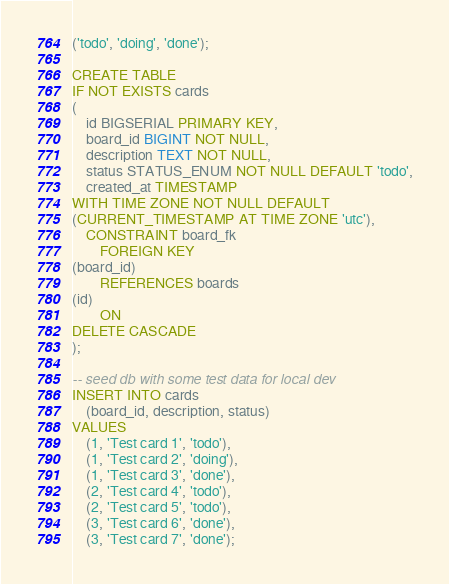Convert code to text. <code><loc_0><loc_0><loc_500><loc_500><_SQL_>('todo', 'doing', 'done');

CREATE TABLE
IF NOT EXISTS cards
(
    id BIGSERIAL PRIMARY KEY,
    board_id BIGINT NOT NULL,
    description TEXT NOT NULL,
    status STATUS_ENUM NOT NULL DEFAULT 'todo',
    created_at TIMESTAMP
WITH TIME ZONE NOT NULL DEFAULT
(CURRENT_TIMESTAMP AT TIME ZONE 'utc'),
    CONSTRAINT board_fk
        FOREIGN KEY
(board_id)
        REFERENCES boards
(id)
        ON
DELETE CASCADE
);

-- seed db with some test data for local dev
INSERT INTO cards
    (board_id, description, status)
VALUES
    (1, 'Test card 1', 'todo'),
    (1, 'Test card 2', 'doing'),
    (1, 'Test card 3', 'done'),
    (2, 'Test card 4', 'todo'),
    (2, 'Test card 5', 'todo'),
    (3, 'Test card 6', 'done'),
    (3, 'Test card 7', 'done');
</code> 